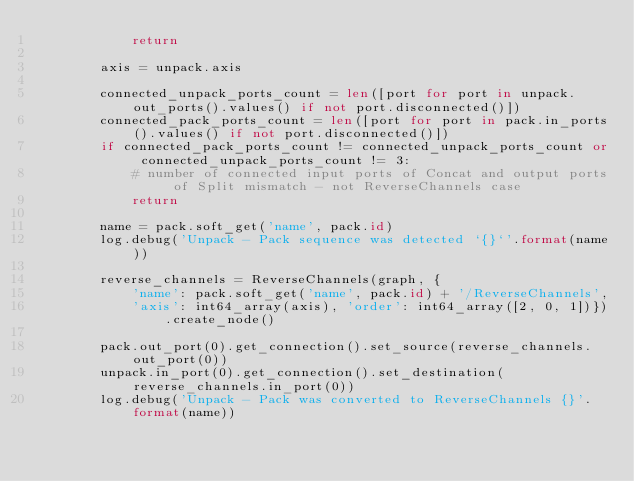<code> <loc_0><loc_0><loc_500><loc_500><_Python_>            return

        axis = unpack.axis

        connected_unpack_ports_count = len([port for port in unpack.out_ports().values() if not port.disconnected()])
        connected_pack_ports_count = len([port for port in pack.in_ports().values() if not port.disconnected()])
        if connected_pack_ports_count != connected_unpack_ports_count or connected_unpack_ports_count != 3:
            # number of connected input ports of Concat and output ports of Split mismatch - not ReverseChannels case
            return

        name = pack.soft_get('name', pack.id)
        log.debug('Unpack - Pack sequence was detected `{}`'.format(name))

        reverse_channels = ReverseChannels(graph, {
            'name': pack.soft_get('name', pack.id) + '/ReverseChannels',
            'axis': int64_array(axis), 'order': int64_array([2, 0, 1])}).create_node()

        pack.out_port(0).get_connection().set_source(reverse_channels.out_port(0))
        unpack.in_port(0).get_connection().set_destination(reverse_channels.in_port(0))
        log.debug('Unpack - Pack was converted to ReverseChannels {}'.format(name))
</code> 